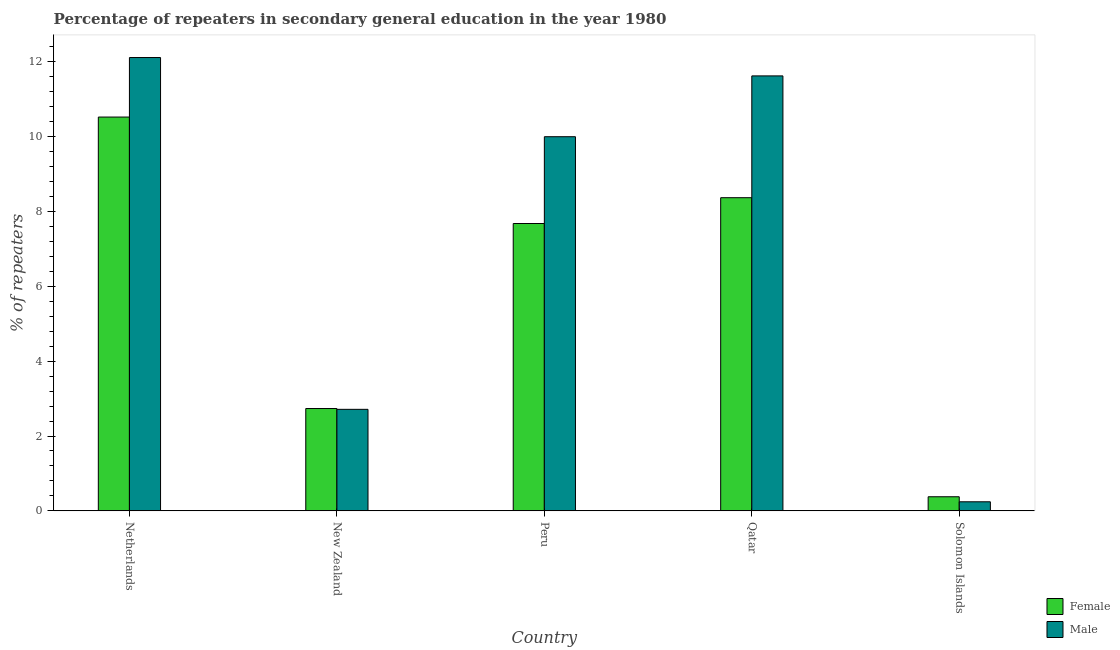How many different coloured bars are there?
Provide a succinct answer. 2. How many groups of bars are there?
Provide a short and direct response. 5. Are the number of bars on each tick of the X-axis equal?
Your answer should be compact. Yes. How many bars are there on the 2nd tick from the left?
Ensure brevity in your answer.  2. How many bars are there on the 2nd tick from the right?
Your response must be concise. 2. What is the percentage of male repeaters in Solomon Islands?
Ensure brevity in your answer.  0.24. Across all countries, what is the maximum percentage of female repeaters?
Give a very brief answer. 10.53. Across all countries, what is the minimum percentage of male repeaters?
Give a very brief answer. 0.24. In which country was the percentage of male repeaters maximum?
Offer a terse response. Netherlands. In which country was the percentage of female repeaters minimum?
Your answer should be compact. Solomon Islands. What is the total percentage of male repeaters in the graph?
Your response must be concise. 36.7. What is the difference between the percentage of female repeaters in Peru and that in Qatar?
Your answer should be very brief. -0.69. What is the difference between the percentage of female repeaters in Solomon Islands and the percentage of male repeaters in Qatar?
Provide a succinct answer. -11.25. What is the average percentage of female repeaters per country?
Offer a terse response. 5.94. What is the difference between the percentage of female repeaters and percentage of male repeaters in Netherlands?
Provide a short and direct response. -1.59. What is the ratio of the percentage of male repeaters in Netherlands to that in Solomon Islands?
Ensure brevity in your answer.  50.16. Is the difference between the percentage of male repeaters in Netherlands and Qatar greater than the difference between the percentage of female repeaters in Netherlands and Qatar?
Your response must be concise. No. What is the difference between the highest and the second highest percentage of male repeaters?
Your answer should be compact. 0.49. What is the difference between the highest and the lowest percentage of male repeaters?
Ensure brevity in your answer.  11.88. How many bars are there?
Offer a terse response. 10. Are all the bars in the graph horizontal?
Your answer should be very brief. No. Are the values on the major ticks of Y-axis written in scientific E-notation?
Make the answer very short. No. Does the graph contain any zero values?
Your answer should be compact. No. What is the title of the graph?
Offer a terse response. Percentage of repeaters in secondary general education in the year 1980. What is the label or title of the X-axis?
Ensure brevity in your answer.  Country. What is the label or title of the Y-axis?
Your answer should be very brief. % of repeaters. What is the % of repeaters of Female in Netherlands?
Keep it short and to the point. 10.53. What is the % of repeaters of Male in Netherlands?
Your answer should be very brief. 12.12. What is the % of repeaters in Female in New Zealand?
Provide a short and direct response. 2.73. What is the % of repeaters in Male in New Zealand?
Provide a short and direct response. 2.71. What is the % of repeaters in Female in Peru?
Provide a short and direct response. 7.68. What is the % of repeaters of Male in Peru?
Keep it short and to the point. 10. What is the % of repeaters in Female in Qatar?
Make the answer very short. 8.37. What is the % of repeaters in Male in Qatar?
Your answer should be compact. 11.63. What is the % of repeaters in Female in Solomon Islands?
Provide a short and direct response. 0.38. What is the % of repeaters in Male in Solomon Islands?
Offer a very short reply. 0.24. Across all countries, what is the maximum % of repeaters in Female?
Your answer should be very brief. 10.53. Across all countries, what is the maximum % of repeaters of Male?
Make the answer very short. 12.12. Across all countries, what is the minimum % of repeaters in Female?
Ensure brevity in your answer.  0.38. Across all countries, what is the minimum % of repeaters of Male?
Your response must be concise. 0.24. What is the total % of repeaters of Female in the graph?
Make the answer very short. 29.69. What is the total % of repeaters in Male in the graph?
Your response must be concise. 36.7. What is the difference between the % of repeaters in Female in Netherlands and that in New Zealand?
Make the answer very short. 7.79. What is the difference between the % of repeaters of Male in Netherlands and that in New Zealand?
Your answer should be very brief. 9.4. What is the difference between the % of repeaters of Female in Netherlands and that in Peru?
Your answer should be very brief. 2.85. What is the difference between the % of repeaters of Male in Netherlands and that in Peru?
Your response must be concise. 2.12. What is the difference between the % of repeaters in Female in Netherlands and that in Qatar?
Your response must be concise. 2.16. What is the difference between the % of repeaters of Male in Netherlands and that in Qatar?
Your response must be concise. 0.49. What is the difference between the % of repeaters in Female in Netherlands and that in Solomon Islands?
Make the answer very short. 10.15. What is the difference between the % of repeaters in Male in Netherlands and that in Solomon Islands?
Provide a succinct answer. 11.88. What is the difference between the % of repeaters in Female in New Zealand and that in Peru?
Your answer should be very brief. -4.95. What is the difference between the % of repeaters in Male in New Zealand and that in Peru?
Offer a terse response. -7.29. What is the difference between the % of repeaters of Female in New Zealand and that in Qatar?
Offer a very short reply. -5.64. What is the difference between the % of repeaters in Male in New Zealand and that in Qatar?
Keep it short and to the point. -8.91. What is the difference between the % of repeaters of Female in New Zealand and that in Solomon Islands?
Your answer should be very brief. 2.36. What is the difference between the % of repeaters of Male in New Zealand and that in Solomon Islands?
Provide a succinct answer. 2.47. What is the difference between the % of repeaters in Female in Peru and that in Qatar?
Offer a terse response. -0.69. What is the difference between the % of repeaters of Male in Peru and that in Qatar?
Keep it short and to the point. -1.63. What is the difference between the % of repeaters in Female in Peru and that in Solomon Islands?
Offer a terse response. 7.3. What is the difference between the % of repeaters in Male in Peru and that in Solomon Islands?
Offer a terse response. 9.76. What is the difference between the % of repeaters in Female in Qatar and that in Solomon Islands?
Give a very brief answer. 7.99. What is the difference between the % of repeaters of Male in Qatar and that in Solomon Islands?
Ensure brevity in your answer.  11.38. What is the difference between the % of repeaters in Female in Netherlands and the % of repeaters in Male in New Zealand?
Provide a succinct answer. 7.81. What is the difference between the % of repeaters in Female in Netherlands and the % of repeaters in Male in Peru?
Keep it short and to the point. 0.53. What is the difference between the % of repeaters in Female in Netherlands and the % of repeaters in Male in Qatar?
Make the answer very short. -1.1. What is the difference between the % of repeaters in Female in Netherlands and the % of repeaters in Male in Solomon Islands?
Offer a very short reply. 10.28. What is the difference between the % of repeaters of Female in New Zealand and the % of repeaters of Male in Peru?
Your response must be concise. -7.27. What is the difference between the % of repeaters of Female in New Zealand and the % of repeaters of Male in Qatar?
Make the answer very short. -8.89. What is the difference between the % of repeaters in Female in New Zealand and the % of repeaters in Male in Solomon Islands?
Your response must be concise. 2.49. What is the difference between the % of repeaters of Female in Peru and the % of repeaters of Male in Qatar?
Provide a short and direct response. -3.95. What is the difference between the % of repeaters of Female in Peru and the % of repeaters of Male in Solomon Islands?
Provide a succinct answer. 7.44. What is the difference between the % of repeaters of Female in Qatar and the % of repeaters of Male in Solomon Islands?
Offer a terse response. 8.13. What is the average % of repeaters of Female per country?
Offer a very short reply. 5.94. What is the average % of repeaters in Male per country?
Give a very brief answer. 7.34. What is the difference between the % of repeaters of Female and % of repeaters of Male in Netherlands?
Offer a very short reply. -1.59. What is the difference between the % of repeaters of Female and % of repeaters of Male in New Zealand?
Your answer should be compact. 0.02. What is the difference between the % of repeaters of Female and % of repeaters of Male in Peru?
Offer a very short reply. -2.32. What is the difference between the % of repeaters of Female and % of repeaters of Male in Qatar?
Your response must be concise. -3.26. What is the difference between the % of repeaters of Female and % of repeaters of Male in Solomon Islands?
Keep it short and to the point. 0.13. What is the ratio of the % of repeaters in Female in Netherlands to that in New Zealand?
Your response must be concise. 3.85. What is the ratio of the % of repeaters of Male in Netherlands to that in New Zealand?
Keep it short and to the point. 4.47. What is the ratio of the % of repeaters of Female in Netherlands to that in Peru?
Ensure brevity in your answer.  1.37. What is the ratio of the % of repeaters in Male in Netherlands to that in Peru?
Offer a very short reply. 1.21. What is the ratio of the % of repeaters in Female in Netherlands to that in Qatar?
Provide a short and direct response. 1.26. What is the ratio of the % of repeaters in Male in Netherlands to that in Qatar?
Ensure brevity in your answer.  1.04. What is the ratio of the % of repeaters of Female in Netherlands to that in Solomon Islands?
Offer a terse response. 27.97. What is the ratio of the % of repeaters of Male in Netherlands to that in Solomon Islands?
Provide a succinct answer. 50.16. What is the ratio of the % of repeaters in Female in New Zealand to that in Peru?
Offer a terse response. 0.36. What is the ratio of the % of repeaters of Male in New Zealand to that in Peru?
Provide a succinct answer. 0.27. What is the ratio of the % of repeaters in Female in New Zealand to that in Qatar?
Your answer should be compact. 0.33. What is the ratio of the % of repeaters of Male in New Zealand to that in Qatar?
Make the answer very short. 0.23. What is the ratio of the % of repeaters of Female in New Zealand to that in Solomon Islands?
Ensure brevity in your answer.  7.27. What is the ratio of the % of repeaters in Male in New Zealand to that in Solomon Islands?
Make the answer very short. 11.23. What is the ratio of the % of repeaters in Female in Peru to that in Qatar?
Your response must be concise. 0.92. What is the ratio of the % of repeaters of Male in Peru to that in Qatar?
Make the answer very short. 0.86. What is the ratio of the % of repeaters in Female in Peru to that in Solomon Islands?
Provide a succinct answer. 20.41. What is the ratio of the % of repeaters of Male in Peru to that in Solomon Islands?
Offer a very short reply. 41.4. What is the ratio of the % of repeaters of Female in Qatar to that in Solomon Islands?
Keep it short and to the point. 22.24. What is the ratio of the % of repeaters of Male in Qatar to that in Solomon Islands?
Give a very brief answer. 48.13. What is the difference between the highest and the second highest % of repeaters of Female?
Ensure brevity in your answer.  2.16. What is the difference between the highest and the second highest % of repeaters in Male?
Your answer should be compact. 0.49. What is the difference between the highest and the lowest % of repeaters of Female?
Your answer should be very brief. 10.15. What is the difference between the highest and the lowest % of repeaters in Male?
Your answer should be compact. 11.88. 